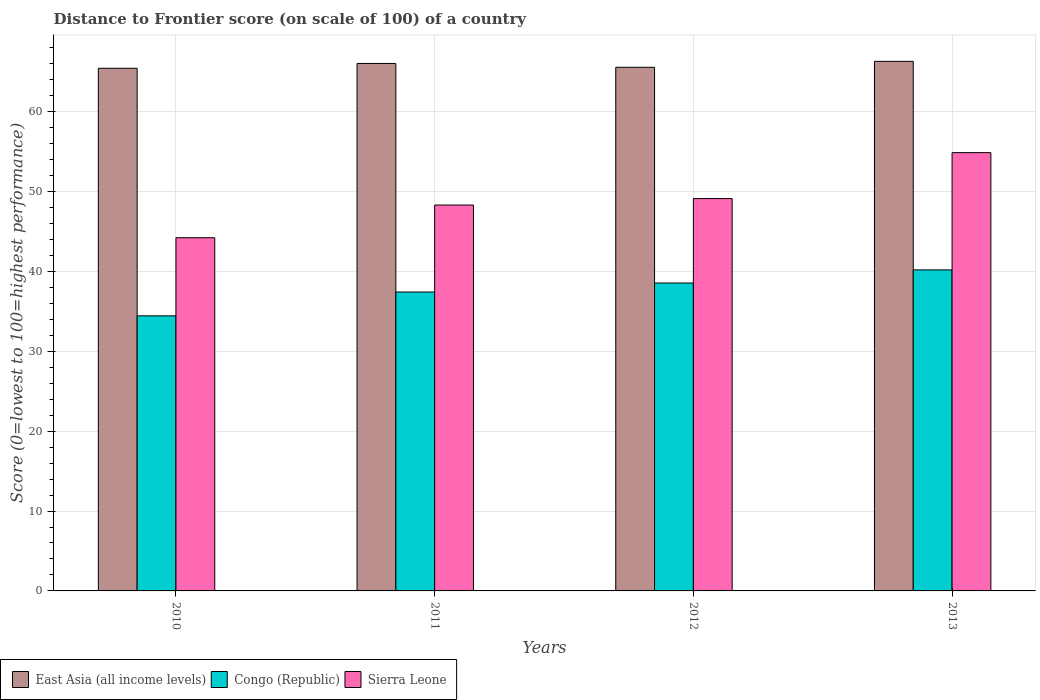How many different coloured bars are there?
Keep it short and to the point. 3. How many groups of bars are there?
Provide a succinct answer. 4. Are the number of bars on each tick of the X-axis equal?
Offer a very short reply. Yes. How many bars are there on the 3rd tick from the left?
Provide a succinct answer. 3. What is the distance to frontier score of in Sierra Leone in 2010?
Provide a short and direct response. 44.22. Across all years, what is the maximum distance to frontier score of in Congo (Republic)?
Offer a very short reply. 40.19. Across all years, what is the minimum distance to frontier score of in Sierra Leone?
Ensure brevity in your answer.  44.22. In which year was the distance to frontier score of in East Asia (all income levels) maximum?
Keep it short and to the point. 2013. What is the total distance to frontier score of in Sierra Leone in the graph?
Offer a very short reply. 196.52. What is the difference between the distance to frontier score of in East Asia (all income levels) in 2011 and that in 2013?
Provide a short and direct response. -0.26. What is the difference between the distance to frontier score of in East Asia (all income levels) in 2011 and the distance to frontier score of in Congo (Republic) in 2012?
Provide a short and direct response. 27.49. What is the average distance to frontier score of in Sierra Leone per year?
Provide a short and direct response. 49.13. In the year 2013, what is the difference between the distance to frontier score of in East Asia (all income levels) and distance to frontier score of in Sierra Leone?
Ensure brevity in your answer.  11.43. In how many years, is the distance to frontier score of in East Asia (all income levels) greater than 54?
Ensure brevity in your answer.  4. What is the ratio of the distance to frontier score of in Sierra Leone in 2010 to that in 2012?
Provide a short and direct response. 0.9. Is the difference between the distance to frontier score of in East Asia (all income levels) in 2011 and 2013 greater than the difference between the distance to frontier score of in Sierra Leone in 2011 and 2013?
Offer a terse response. Yes. What is the difference between the highest and the second highest distance to frontier score of in Congo (Republic)?
Keep it short and to the point. 1.64. What is the difference between the highest and the lowest distance to frontier score of in Congo (Republic)?
Provide a short and direct response. 5.75. In how many years, is the distance to frontier score of in Sierra Leone greater than the average distance to frontier score of in Sierra Leone taken over all years?
Give a very brief answer. 1. Is the sum of the distance to frontier score of in Congo (Republic) in 2010 and 2011 greater than the maximum distance to frontier score of in East Asia (all income levels) across all years?
Provide a short and direct response. Yes. What does the 3rd bar from the left in 2013 represents?
Your answer should be very brief. Sierra Leone. What does the 3rd bar from the right in 2011 represents?
Your answer should be very brief. East Asia (all income levels). How many bars are there?
Provide a short and direct response. 12. How many years are there in the graph?
Your response must be concise. 4. Are the values on the major ticks of Y-axis written in scientific E-notation?
Provide a succinct answer. No. Does the graph contain any zero values?
Ensure brevity in your answer.  No. Does the graph contain grids?
Keep it short and to the point. Yes. Where does the legend appear in the graph?
Give a very brief answer. Bottom left. How are the legend labels stacked?
Offer a very short reply. Horizontal. What is the title of the graph?
Provide a succinct answer. Distance to Frontier score (on scale of 100) of a country. Does "Malawi" appear as one of the legend labels in the graph?
Offer a terse response. No. What is the label or title of the X-axis?
Provide a short and direct response. Years. What is the label or title of the Y-axis?
Ensure brevity in your answer.  Score (0=lowest to 100=highest performance). What is the Score (0=lowest to 100=highest performance) in East Asia (all income levels) in 2010?
Ensure brevity in your answer.  65.43. What is the Score (0=lowest to 100=highest performance) in Congo (Republic) in 2010?
Your answer should be very brief. 34.44. What is the Score (0=lowest to 100=highest performance) in Sierra Leone in 2010?
Offer a very short reply. 44.22. What is the Score (0=lowest to 100=highest performance) of East Asia (all income levels) in 2011?
Ensure brevity in your answer.  66.04. What is the Score (0=lowest to 100=highest performance) in Congo (Republic) in 2011?
Your answer should be very brief. 37.42. What is the Score (0=lowest to 100=highest performance) of Sierra Leone in 2011?
Give a very brief answer. 48.31. What is the Score (0=lowest to 100=highest performance) of East Asia (all income levels) in 2012?
Your answer should be compact. 65.56. What is the Score (0=lowest to 100=highest performance) in Congo (Republic) in 2012?
Your response must be concise. 38.55. What is the Score (0=lowest to 100=highest performance) of Sierra Leone in 2012?
Give a very brief answer. 49.12. What is the Score (0=lowest to 100=highest performance) of East Asia (all income levels) in 2013?
Ensure brevity in your answer.  66.3. What is the Score (0=lowest to 100=highest performance) in Congo (Republic) in 2013?
Provide a succinct answer. 40.19. What is the Score (0=lowest to 100=highest performance) of Sierra Leone in 2013?
Offer a very short reply. 54.87. Across all years, what is the maximum Score (0=lowest to 100=highest performance) in East Asia (all income levels)?
Keep it short and to the point. 66.3. Across all years, what is the maximum Score (0=lowest to 100=highest performance) in Congo (Republic)?
Your response must be concise. 40.19. Across all years, what is the maximum Score (0=lowest to 100=highest performance) of Sierra Leone?
Ensure brevity in your answer.  54.87. Across all years, what is the minimum Score (0=lowest to 100=highest performance) in East Asia (all income levels)?
Provide a short and direct response. 65.43. Across all years, what is the minimum Score (0=lowest to 100=highest performance) of Congo (Republic)?
Your answer should be very brief. 34.44. Across all years, what is the minimum Score (0=lowest to 100=highest performance) in Sierra Leone?
Your answer should be very brief. 44.22. What is the total Score (0=lowest to 100=highest performance) of East Asia (all income levels) in the graph?
Provide a short and direct response. 263.32. What is the total Score (0=lowest to 100=highest performance) in Congo (Republic) in the graph?
Provide a succinct answer. 150.6. What is the total Score (0=lowest to 100=highest performance) of Sierra Leone in the graph?
Offer a terse response. 196.52. What is the difference between the Score (0=lowest to 100=highest performance) of East Asia (all income levels) in 2010 and that in 2011?
Offer a very short reply. -0.6. What is the difference between the Score (0=lowest to 100=highest performance) of Congo (Republic) in 2010 and that in 2011?
Keep it short and to the point. -2.98. What is the difference between the Score (0=lowest to 100=highest performance) of Sierra Leone in 2010 and that in 2011?
Keep it short and to the point. -4.09. What is the difference between the Score (0=lowest to 100=highest performance) in East Asia (all income levels) in 2010 and that in 2012?
Your answer should be compact. -0.12. What is the difference between the Score (0=lowest to 100=highest performance) of Congo (Republic) in 2010 and that in 2012?
Your response must be concise. -4.11. What is the difference between the Score (0=lowest to 100=highest performance) in East Asia (all income levels) in 2010 and that in 2013?
Your response must be concise. -0.87. What is the difference between the Score (0=lowest to 100=highest performance) of Congo (Republic) in 2010 and that in 2013?
Offer a very short reply. -5.75. What is the difference between the Score (0=lowest to 100=highest performance) in Sierra Leone in 2010 and that in 2013?
Keep it short and to the point. -10.65. What is the difference between the Score (0=lowest to 100=highest performance) in East Asia (all income levels) in 2011 and that in 2012?
Offer a very short reply. 0.48. What is the difference between the Score (0=lowest to 100=highest performance) of Congo (Republic) in 2011 and that in 2012?
Your answer should be very brief. -1.13. What is the difference between the Score (0=lowest to 100=highest performance) of Sierra Leone in 2011 and that in 2012?
Your answer should be compact. -0.81. What is the difference between the Score (0=lowest to 100=highest performance) of East Asia (all income levels) in 2011 and that in 2013?
Offer a terse response. -0.26. What is the difference between the Score (0=lowest to 100=highest performance) in Congo (Republic) in 2011 and that in 2013?
Provide a succinct answer. -2.77. What is the difference between the Score (0=lowest to 100=highest performance) in Sierra Leone in 2011 and that in 2013?
Offer a terse response. -6.56. What is the difference between the Score (0=lowest to 100=highest performance) of East Asia (all income levels) in 2012 and that in 2013?
Your answer should be very brief. -0.74. What is the difference between the Score (0=lowest to 100=highest performance) in Congo (Republic) in 2012 and that in 2013?
Keep it short and to the point. -1.64. What is the difference between the Score (0=lowest to 100=highest performance) of Sierra Leone in 2012 and that in 2013?
Keep it short and to the point. -5.75. What is the difference between the Score (0=lowest to 100=highest performance) of East Asia (all income levels) in 2010 and the Score (0=lowest to 100=highest performance) of Congo (Republic) in 2011?
Provide a short and direct response. 28.01. What is the difference between the Score (0=lowest to 100=highest performance) in East Asia (all income levels) in 2010 and the Score (0=lowest to 100=highest performance) in Sierra Leone in 2011?
Your answer should be compact. 17.12. What is the difference between the Score (0=lowest to 100=highest performance) in Congo (Republic) in 2010 and the Score (0=lowest to 100=highest performance) in Sierra Leone in 2011?
Your answer should be compact. -13.87. What is the difference between the Score (0=lowest to 100=highest performance) in East Asia (all income levels) in 2010 and the Score (0=lowest to 100=highest performance) in Congo (Republic) in 2012?
Your answer should be compact. 26.88. What is the difference between the Score (0=lowest to 100=highest performance) of East Asia (all income levels) in 2010 and the Score (0=lowest to 100=highest performance) of Sierra Leone in 2012?
Provide a short and direct response. 16.31. What is the difference between the Score (0=lowest to 100=highest performance) in Congo (Republic) in 2010 and the Score (0=lowest to 100=highest performance) in Sierra Leone in 2012?
Keep it short and to the point. -14.68. What is the difference between the Score (0=lowest to 100=highest performance) of East Asia (all income levels) in 2010 and the Score (0=lowest to 100=highest performance) of Congo (Republic) in 2013?
Provide a succinct answer. 25.24. What is the difference between the Score (0=lowest to 100=highest performance) of East Asia (all income levels) in 2010 and the Score (0=lowest to 100=highest performance) of Sierra Leone in 2013?
Your answer should be very brief. 10.56. What is the difference between the Score (0=lowest to 100=highest performance) in Congo (Republic) in 2010 and the Score (0=lowest to 100=highest performance) in Sierra Leone in 2013?
Offer a very short reply. -20.43. What is the difference between the Score (0=lowest to 100=highest performance) of East Asia (all income levels) in 2011 and the Score (0=lowest to 100=highest performance) of Congo (Republic) in 2012?
Offer a very short reply. 27.49. What is the difference between the Score (0=lowest to 100=highest performance) of East Asia (all income levels) in 2011 and the Score (0=lowest to 100=highest performance) of Sierra Leone in 2012?
Your answer should be very brief. 16.92. What is the difference between the Score (0=lowest to 100=highest performance) of Congo (Republic) in 2011 and the Score (0=lowest to 100=highest performance) of Sierra Leone in 2012?
Ensure brevity in your answer.  -11.7. What is the difference between the Score (0=lowest to 100=highest performance) in East Asia (all income levels) in 2011 and the Score (0=lowest to 100=highest performance) in Congo (Republic) in 2013?
Provide a short and direct response. 25.85. What is the difference between the Score (0=lowest to 100=highest performance) in East Asia (all income levels) in 2011 and the Score (0=lowest to 100=highest performance) in Sierra Leone in 2013?
Ensure brevity in your answer.  11.17. What is the difference between the Score (0=lowest to 100=highest performance) of Congo (Republic) in 2011 and the Score (0=lowest to 100=highest performance) of Sierra Leone in 2013?
Provide a succinct answer. -17.45. What is the difference between the Score (0=lowest to 100=highest performance) in East Asia (all income levels) in 2012 and the Score (0=lowest to 100=highest performance) in Congo (Republic) in 2013?
Keep it short and to the point. 25.37. What is the difference between the Score (0=lowest to 100=highest performance) in East Asia (all income levels) in 2012 and the Score (0=lowest to 100=highest performance) in Sierra Leone in 2013?
Offer a terse response. 10.69. What is the difference between the Score (0=lowest to 100=highest performance) in Congo (Republic) in 2012 and the Score (0=lowest to 100=highest performance) in Sierra Leone in 2013?
Provide a short and direct response. -16.32. What is the average Score (0=lowest to 100=highest performance) of East Asia (all income levels) per year?
Provide a short and direct response. 65.83. What is the average Score (0=lowest to 100=highest performance) in Congo (Republic) per year?
Offer a terse response. 37.65. What is the average Score (0=lowest to 100=highest performance) in Sierra Leone per year?
Provide a succinct answer. 49.13. In the year 2010, what is the difference between the Score (0=lowest to 100=highest performance) of East Asia (all income levels) and Score (0=lowest to 100=highest performance) of Congo (Republic)?
Provide a succinct answer. 30.99. In the year 2010, what is the difference between the Score (0=lowest to 100=highest performance) of East Asia (all income levels) and Score (0=lowest to 100=highest performance) of Sierra Leone?
Offer a terse response. 21.21. In the year 2010, what is the difference between the Score (0=lowest to 100=highest performance) of Congo (Republic) and Score (0=lowest to 100=highest performance) of Sierra Leone?
Provide a short and direct response. -9.78. In the year 2011, what is the difference between the Score (0=lowest to 100=highest performance) of East Asia (all income levels) and Score (0=lowest to 100=highest performance) of Congo (Republic)?
Give a very brief answer. 28.62. In the year 2011, what is the difference between the Score (0=lowest to 100=highest performance) of East Asia (all income levels) and Score (0=lowest to 100=highest performance) of Sierra Leone?
Ensure brevity in your answer.  17.73. In the year 2011, what is the difference between the Score (0=lowest to 100=highest performance) in Congo (Republic) and Score (0=lowest to 100=highest performance) in Sierra Leone?
Your answer should be compact. -10.89. In the year 2012, what is the difference between the Score (0=lowest to 100=highest performance) of East Asia (all income levels) and Score (0=lowest to 100=highest performance) of Congo (Republic)?
Keep it short and to the point. 27.01. In the year 2012, what is the difference between the Score (0=lowest to 100=highest performance) in East Asia (all income levels) and Score (0=lowest to 100=highest performance) in Sierra Leone?
Provide a succinct answer. 16.44. In the year 2012, what is the difference between the Score (0=lowest to 100=highest performance) in Congo (Republic) and Score (0=lowest to 100=highest performance) in Sierra Leone?
Your response must be concise. -10.57. In the year 2013, what is the difference between the Score (0=lowest to 100=highest performance) in East Asia (all income levels) and Score (0=lowest to 100=highest performance) in Congo (Republic)?
Ensure brevity in your answer.  26.11. In the year 2013, what is the difference between the Score (0=lowest to 100=highest performance) in East Asia (all income levels) and Score (0=lowest to 100=highest performance) in Sierra Leone?
Make the answer very short. 11.43. In the year 2013, what is the difference between the Score (0=lowest to 100=highest performance) in Congo (Republic) and Score (0=lowest to 100=highest performance) in Sierra Leone?
Offer a very short reply. -14.68. What is the ratio of the Score (0=lowest to 100=highest performance) of East Asia (all income levels) in 2010 to that in 2011?
Your answer should be compact. 0.99. What is the ratio of the Score (0=lowest to 100=highest performance) in Congo (Republic) in 2010 to that in 2011?
Your response must be concise. 0.92. What is the ratio of the Score (0=lowest to 100=highest performance) in Sierra Leone in 2010 to that in 2011?
Provide a succinct answer. 0.92. What is the ratio of the Score (0=lowest to 100=highest performance) of Congo (Republic) in 2010 to that in 2012?
Your response must be concise. 0.89. What is the ratio of the Score (0=lowest to 100=highest performance) in Sierra Leone in 2010 to that in 2012?
Offer a terse response. 0.9. What is the ratio of the Score (0=lowest to 100=highest performance) in East Asia (all income levels) in 2010 to that in 2013?
Keep it short and to the point. 0.99. What is the ratio of the Score (0=lowest to 100=highest performance) in Congo (Republic) in 2010 to that in 2013?
Your response must be concise. 0.86. What is the ratio of the Score (0=lowest to 100=highest performance) of Sierra Leone in 2010 to that in 2013?
Keep it short and to the point. 0.81. What is the ratio of the Score (0=lowest to 100=highest performance) of East Asia (all income levels) in 2011 to that in 2012?
Offer a very short reply. 1.01. What is the ratio of the Score (0=lowest to 100=highest performance) of Congo (Republic) in 2011 to that in 2012?
Your response must be concise. 0.97. What is the ratio of the Score (0=lowest to 100=highest performance) of Sierra Leone in 2011 to that in 2012?
Your answer should be compact. 0.98. What is the ratio of the Score (0=lowest to 100=highest performance) in East Asia (all income levels) in 2011 to that in 2013?
Provide a short and direct response. 1. What is the ratio of the Score (0=lowest to 100=highest performance) in Congo (Republic) in 2011 to that in 2013?
Provide a succinct answer. 0.93. What is the ratio of the Score (0=lowest to 100=highest performance) of Sierra Leone in 2011 to that in 2013?
Ensure brevity in your answer.  0.88. What is the ratio of the Score (0=lowest to 100=highest performance) in Congo (Republic) in 2012 to that in 2013?
Keep it short and to the point. 0.96. What is the ratio of the Score (0=lowest to 100=highest performance) in Sierra Leone in 2012 to that in 2013?
Provide a short and direct response. 0.9. What is the difference between the highest and the second highest Score (0=lowest to 100=highest performance) of East Asia (all income levels)?
Your answer should be very brief. 0.26. What is the difference between the highest and the second highest Score (0=lowest to 100=highest performance) in Congo (Republic)?
Offer a very short reply. 1.64. What is the difference between the highest and the second highest Score (0=lowest to 100=highest performance) of Sierra Leone?
Your response must be concise. 5.75. What is the difference between the highest and the lowest Score (0=lowest to 100=highest performance) of East Asia (all income levels)?
Give a very brief answer. 0.87. What is the difference between the highest and the lowest Score (0=lowest to 100=highest performance) in Congo (Republic)?
Provide a succinct answer. 5.75. What is the difference between the highest and the lowest Score (0=lowest to 100=highest performance) of Sierra Leone?
Offer a very short reply. 10.65. 